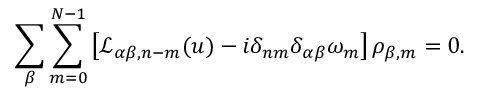<formula> <loc_0><loc_0><loc_500><loc_500>\sum _ { \beta } \sum _ { m = 0 } ^ { N - 1 } \left [ \mathcal { L } _ { \alpha \beta , n - m } ( u ) - i \delta _ { n m } \delta _ { \alpha \beta } \omega _ { m } \right ] \rho _ { \beta , m } = 0 .</formula> 